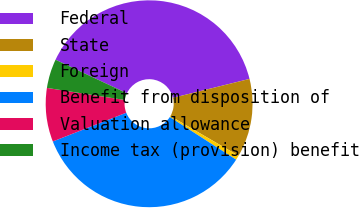Convert chart to OTSL. <chart><loc_0><loc_0><loc_500><loc_500><pie_chart><fcel>Federal<fcel>State<fcel>Foreign<fcel>Benefit from disposition of<fcel>Valuation allowance<fcel>Income tax (provision) benefit<nl><fcel>39.14%<fcel>12.24%<fcel>0.71%<fcel>34.97%<fcel>8.39%<fcel>4.55%<nl></chart> 